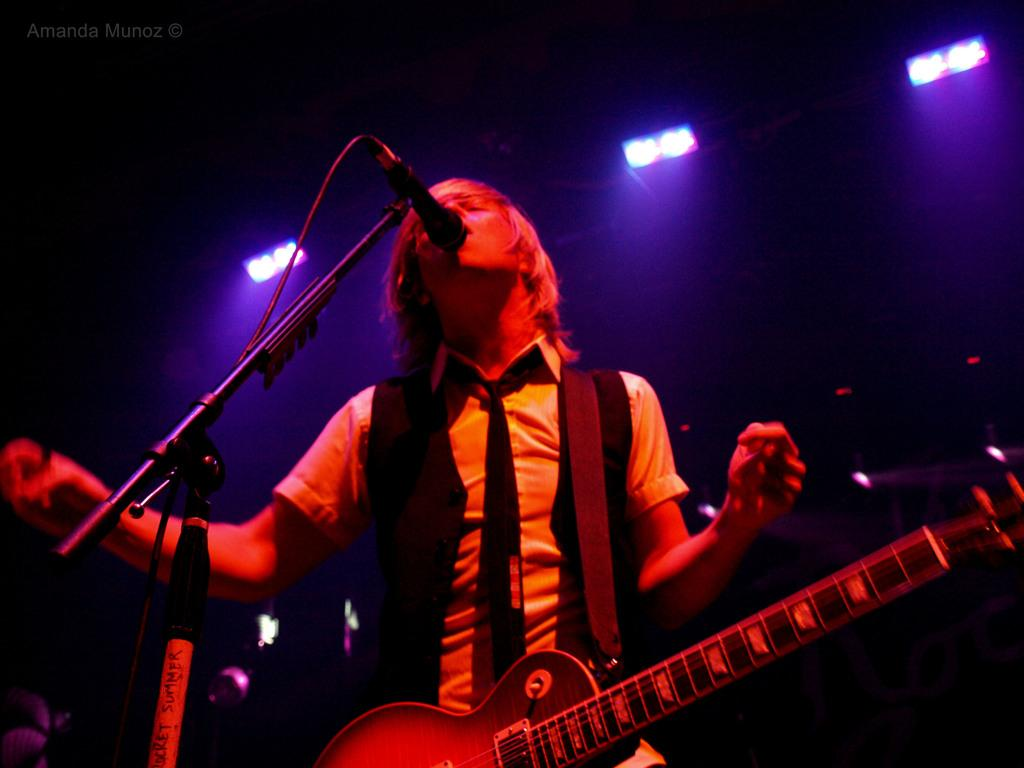What is the main subject of the image? There is a person in the image. Can you describe the person's attire? The person is wearing colorful clothes. What is the person holding in the image? The person is holding a guitar. What can be seen behind the person? The person is standing in front of a mic. How many lights are visible at the top of the image? There are three lights at the top of the image. How many chairs are visible in the image? There are no chairs visible in the image. Is the person in the image currently in jail? There is no indication in the image that the person is in jail. 